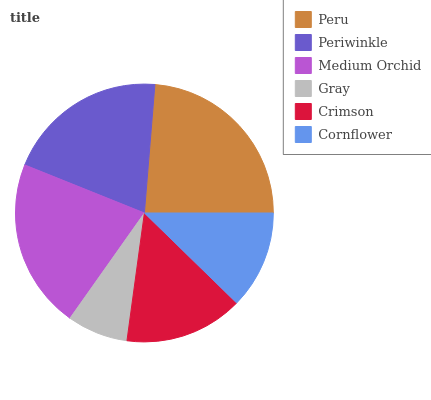Is Gray the minimum?
Answer yes or no. Yes. Is Peru the maximum?
Answer yes or no. Yes. Is Periwinkle the minimum?
Answer yes or no. No. Is Periwinkle the maximum?
Answer yes or no. No. Is Peru greater than Periwinkle?
Answer yes or no. Yes. Is Periwinkle less than Peru?
Answer yes or no. Yes. Is Periwinkle greater than Peru?
Answer yes or no. No. Is Peru less than Periwinkle?
Answer yes or no. No. Is Periwinkle the high median?
Answer yes or no. Yes. Is Crimson the low median?
Answer yes or no. Yes. Is Medium Orchid the high median?
Answer yes or no. No. Is Gray the low median?
Answer yes or no. No. 